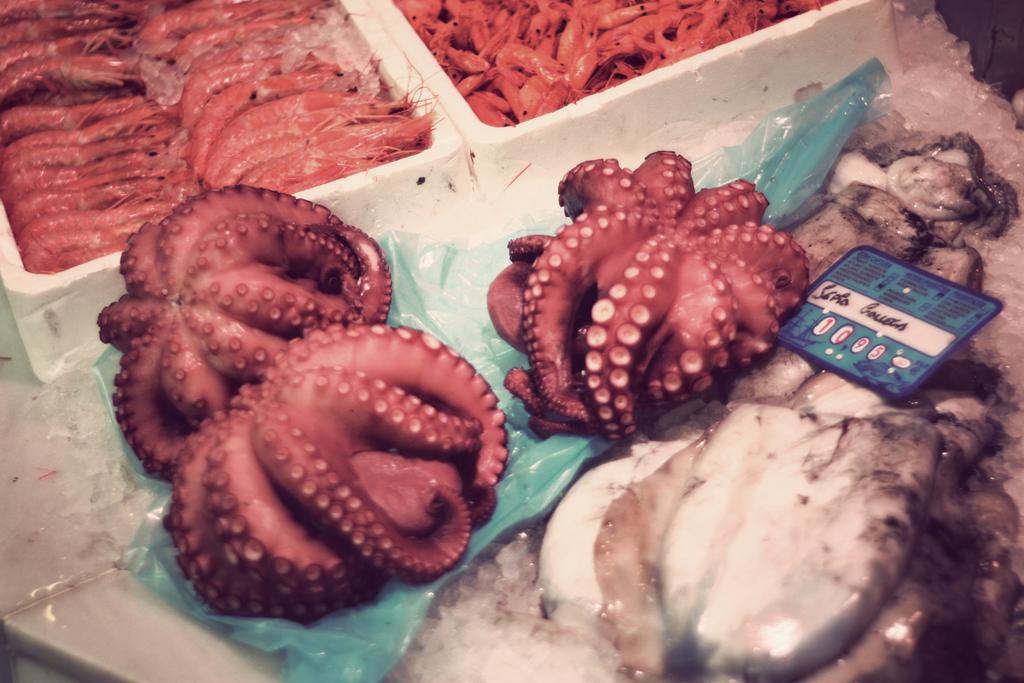Please provide a concise description of this image. In the middle of the picture, we see small fishes are placed on the green cover. Beside that, we see the fishes. We see prawns or some kind of dishes are placed in the white boxes. 